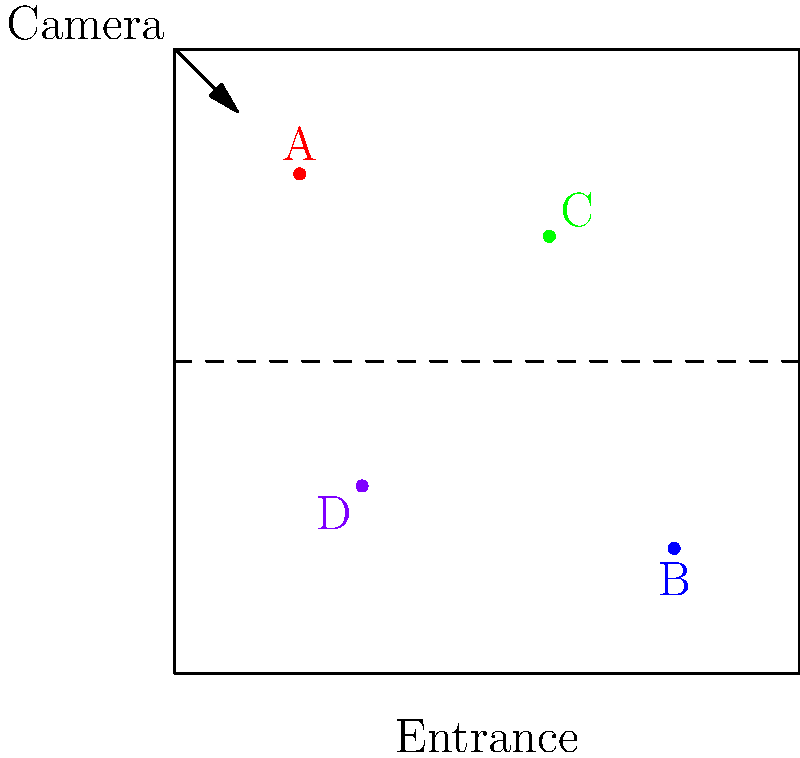Based on the security camera footage of your store layout, which customer's behavior appears most suspicious? To determine the most suspicious customer, let's analyze each customer's position and behavior:

1. Customer A (red dot):
   - Located near the top-left corner
   - Possibly browsing items, but close to a wall/corner
   
2. Customer B (blue dot):
   - Located in the bottom-right area
   - Seems to be in a normal shopping position

3. Customer C (green dot):
   - Located in the upper-middle area
   - In a less crowded part of the store, but not necessarily suspicious

4. Customer D (purple dot):
   - Located in the bottom-left corner
   - Close to the entrance and in a position that could obstruct the view of other areas

Analyzing these positions, Customer D appears most suspicious for the following reasons:
- Positioned near the entrance, which could indicate preparation for a quick exit
- Located in a corner that provides a vantage point of the store while being less visible
- Placement could potentially block the view of other areas from the security camera

While not conclusive, Customer D's position raises more red flags compared to the others, making them the most suspicious based solely on this limited information.
Answer: Customer D 